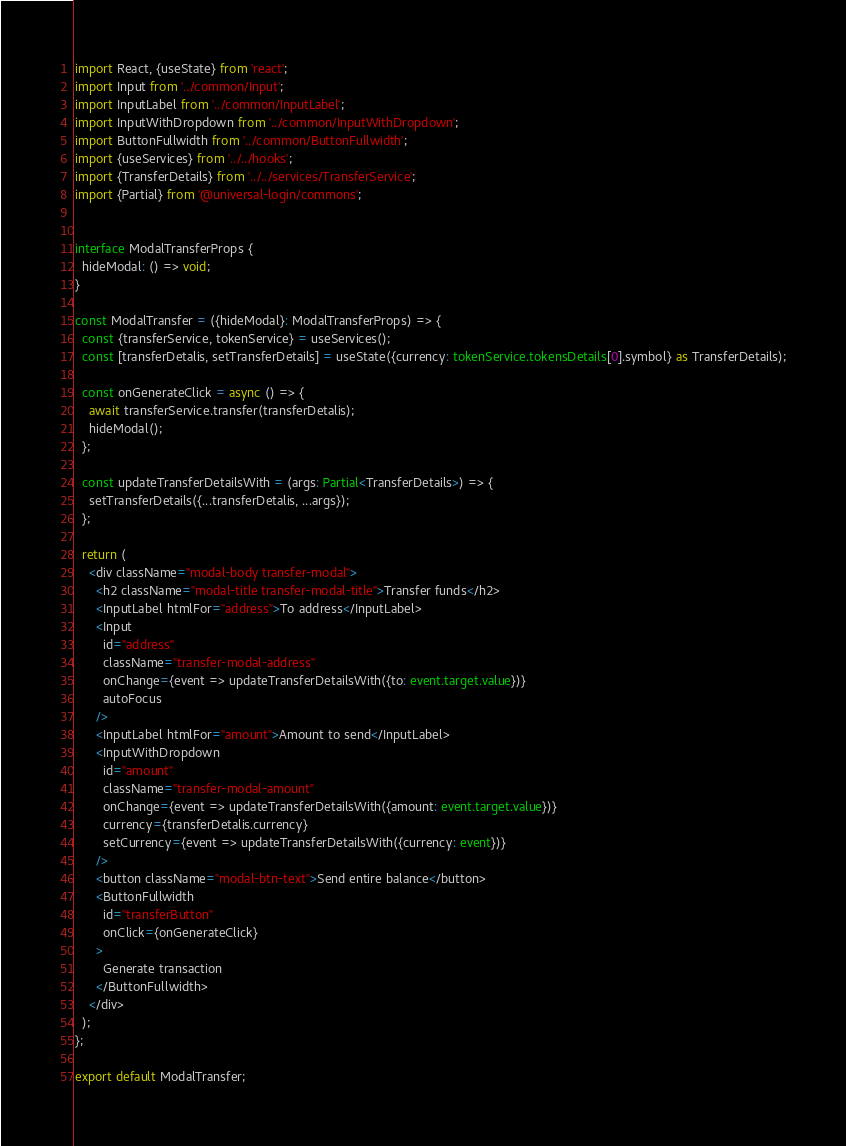<code> <loc_0><loc_0><loc_500><loc_500><_TypeScript_>import React, {useState} from 'react';
import Input from '../common/Input';
import InputLabel from '../common/InputLabel';
import InputWithDropdown from '../common/InputWithDropdown';
import ButtonFullwidth from '../common/ButtonFullwidth';
import {useServices} from '../../hooks';
import {TransferDetails} from '../../services/TransferService';
import {Partial} from '@universal-login/commons';


interface ModalTransferProps {
  hideModal: () => void;
}

const ModalTransfer = ({hideModal}: ModalTransferProps) => {
  const {transferService, tokenService} = useServices();
  const [transferDetalis, setTransferDetails] = useState({currency: tokenService.tokensDetails[0].symbol} as TransferDetails);

  const onGenerateClick = async () => {
    await transferService.transfer(transferDetalis);
    hideModal();
  };

  const updateTransferDetailsWith = (args: Partial<TransferDetails>) => {
    setTransferDetails({...transferDetalis, ...args});
  };

  return (
    <div className="modal-body transfer-modal">
      <h2 className="modal-title transfer-modal-title">Transfer funds</h2>
      <InputLabel htmlFor="address">To address</InputLabel>
      <Input
        id="address"
        className="transfer-modal-address"
        onChange={event => updateTransferDetailsWith({to: event.target.value})}
        autoFocus
      />
      <InputLabel htmlFor="amount">Amount to send</InputLabel>
      <InputWithDropdown
        id="amount"
        className="transfer-modal-amount"
        onChange={event => updateTransferDetailsWith({amount: event.target.value})}
        currency={transferDetalis.currency}
        setCurrency={event => updateTransferDetailsWith({currency: event})}
      />
      <button className="modal-btn-text">Send entire balance</button>
      <ButtonFullwidth
        id="transferButton"
        onClick={onGenerateClick}
      >
        Generate transaction
      </ButtonFullwidth>
    </div>
  );
};

export default ModalTransfer;
</code> 